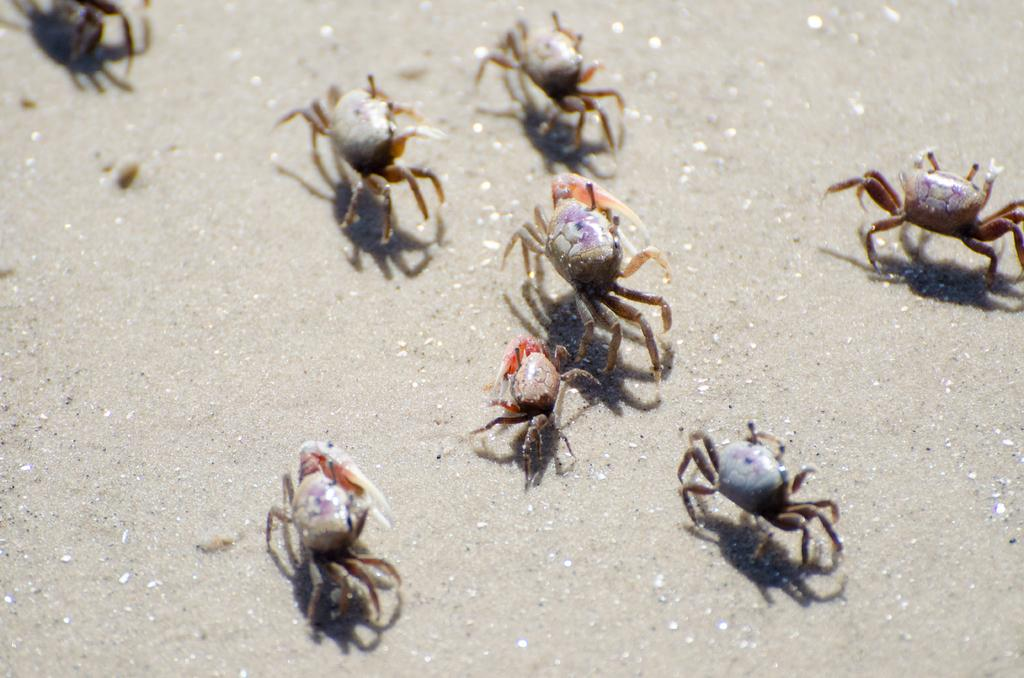What type of animals can be seen on the ground in the image? There are crabs on the ground in the image. What type of education can be seen in the image? There is no reference to education in the image, as it features crabs on the ground. 